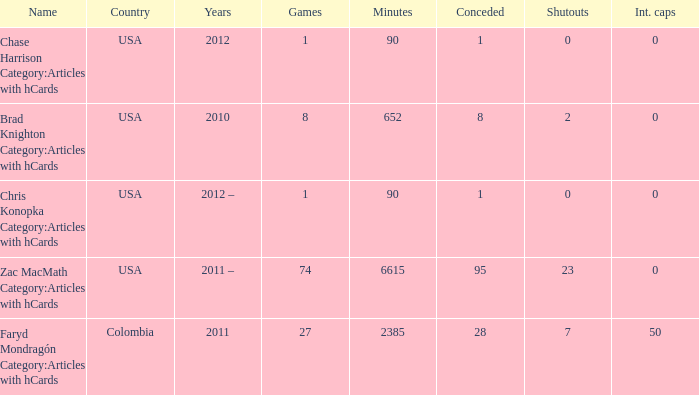For chris konopka category:articles with hcards as the name, which year is it? 2012 –. 